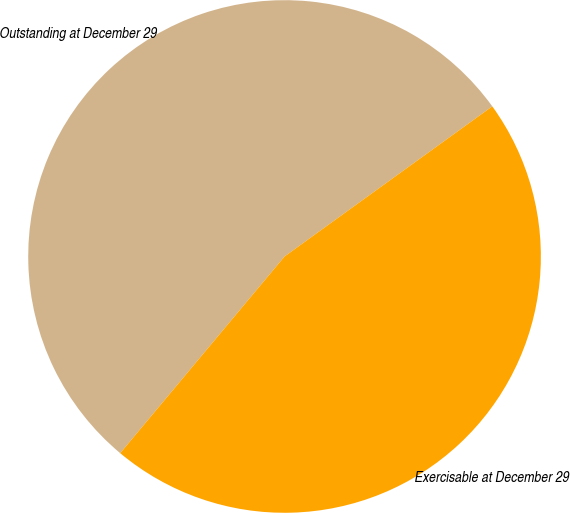Convert chart. <chart><loc_0><loc_0><loc_500><loc_500><pie_chart><fcel>Outstanding at December 29<fcel>Exercisable at December 29<nl><fcel>53.96%<fcel>46.04%<nl></chart> 